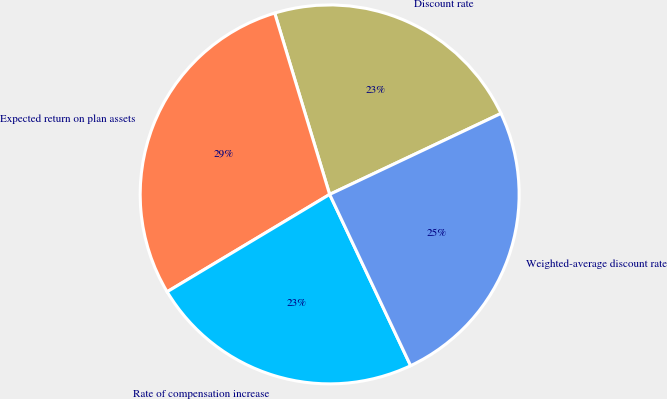Convert chart to OTSL. <chart><loc_0><loc_0><loc_500><loc_500><pie_chart><fcel>Discount rate<fcel>Expected return on plan assets<fcel>Rate of compensation increase<fcel>Weighted-average discount rate<nl><fcel>22.66%<fcel>28.91%<fcel>23.44%<fcel>25.0%<nl></chart> 